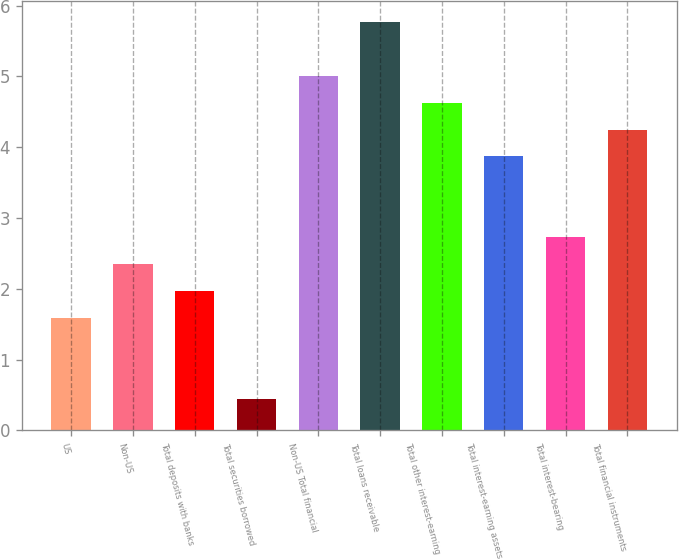Convert chart. <chart><loc_0><loc_0><loc_500><loc_500><bar_chart><fcel>US<fcel>Non-US<fcel>Total deposits with banks<fcel>Total securities borrowed<fcel>Non-US Total financial<fcel>Total loans receivable<fcel>Total other interest-earning<fcel>Total interest-earning assets<fcel>Total interest-bearing<fcel>Total financial instruments<nl><fcel>1.59<fcel>2.35<fcel>1.97<fcel>0.45<fcel>5.01<fcel>5.77<fcel>4.63<fcel>3.87<fcel>2.73<fcel>4.25<nl></chart> 